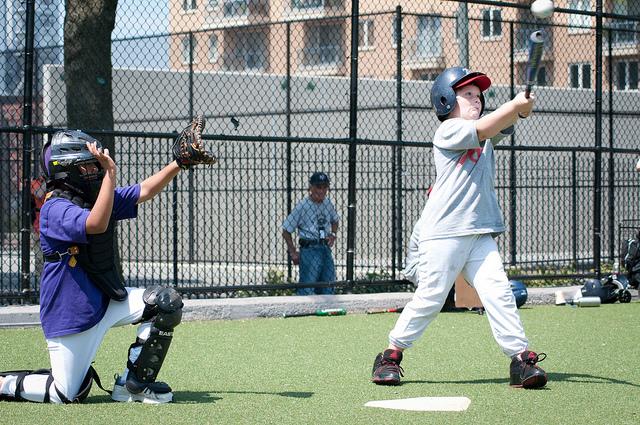What is the color of the helmet?
Quick response, please. Black. Is this a little league game?
Answer briefly. Yes. How far did the ball fly?
Answer briefly. Not far. 